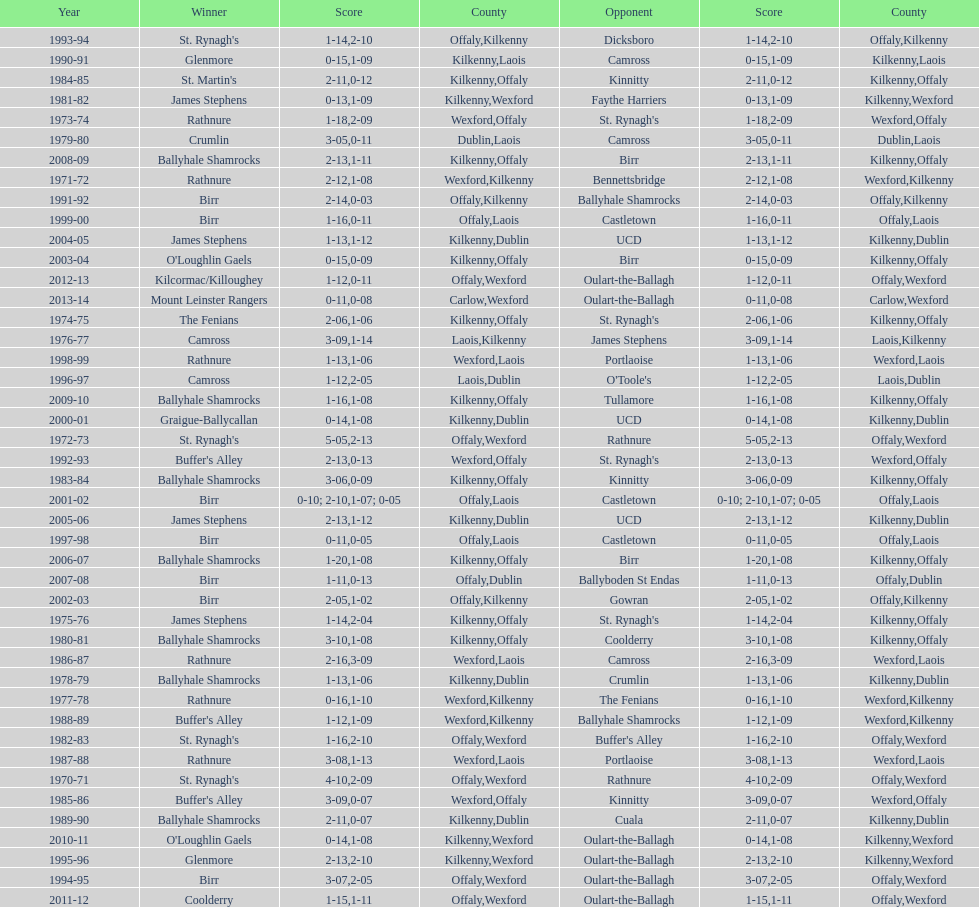James stephens won in 1976-76. who won three years before that? St. Rynagh's. Could you parse the entire table as a dict? {'header': ['Year', 'Winner', 'Score', 'County', 'Opponent', 'Score', 'County'], 'rows': [['1993-94', "St. Rynagh's", '1-14', 'Offaly', 'Dicksboro', '2-10', 'Kilkenny'], ['1990-91', 'Glenmore', '0-15', 'Kilkenny', 'Camross', '1-09', 'Laois'], ['1984-85', "St. Martin's", '2-11', 'Kilkenny', 'Kinnitty', '0-12', 'Offaly'], ['1981-82', 'James Stephens', '0-13', 'Kilkenny', 'Faythe Harriers', '1-09', 'Wexford'], ['1973-74', 'Rathnure', '1-18', 'Wexford', "St. Rynagh's", '2-09', 'Offaly'], ['1979-80', 'Crumlin', '3-05', 'Dublin', 'Camross', '0-11', 'Laois'], ['2008-09', 'Ballyhale Shamrocks', '2-13', 'Kilkenny', 'Birr', '1-11', 'Offaly'], ['1971-72', 'Rathnure', '2-12', 'Wexford', 'Bennettsbridge', '1-08', 'Kilkenny'], ['1991-92', 'Birr', '2-14', 'Offaly', 'Ballyhale Shamrocks', '0-03', 'Kilkenny'], ['1999-00', 'Birr', '1-16', 'Offaly', 'Castletown', '0-11', 'Laois'], ['2004-05', 'James Stephens', '1-13', 'Kilkenny', 'UCD', '1-12', 'Dublin'], ['2003-04', "O'Loughlin Gaels", '0-15', 'Kilkenny', 'Birr', '0-09', 'Offaly'], ['2012-13', 'Kilcormac/Killoughey', '1-12', 'Offaly', 'Oulart-the-Ballagh', '0-11', 'Wexford'], ['2013-14', 'Mount Leinster Rangers', '0-11', 'Carlow', 'Oulart-the-Ballagh', '0-08', 'Wexford'], ['1974-75', 'The Fenians', '2-06', 'Kilkenny', "St. Rynagh's", '1-06', 'Offaly'], ['1976-77', 'Camross', '3-09', 'Laois', 'James Stephens', '1-14', 'Kilkenny'], ['1998-99', 'Rathnure', '1-13', 'Wexford', 'Portlaoise', '1-06', 'Laois'], ['1996-97', 'Camross', '1-12', 'Laois', "O'Toole's", '2-05', 'Dublin'], ['2009-10', 'Ballyhale Shamrocks', '1-16', 'Kilkenny', 'Tullamore', '1-08', 'Offaly'], ['2000-01', 'Graigue-Ballycallan', '0-14', 'Kilkenny', 'UCD', '1-08', 'Dublin'], ['1972-73', "St. Rynagh's", '5-05', 'Offaly', 'Rathnure', '2-13', 'Wexford'], ['1992-93', "Buffer's Alley", '2-13', 'Wexford', "St. Rynagh's", '0-13', 'Offaly'], ['1983-84', 'Ballyhale Shamrocks', '3-06', 'Kilkenny', 'Kinnitty', '0-09', 'Offaly'], ['2001-02', 'Birr', '0-10; 2-10', 'Offaly', 'Castletown', '1-07; 0-05', 'Laois'], ['2005-06', 'James Stephens', '2-13', 'Kilkenny', 'UCD', '1-12', 'Dublin'], ['1997-98', 'Birr', '0-11', 'Offaly', 'Castletown', '0-05', 'Laois'], ['2006-07', 'Ballyhale Shamrocks', '1-20', 'Kilkenny', 'Birr', '1-08', 'Offaly'], ['2007-08', 'Birr', '1-11', 'Offaly', 'Ballyboden St Endas', '0-13', 'Dublin'], ['2002-03', 'Birr', '2-05', 'Offaly', 'Gowran', '1-02', 'Kilkenny'], ['1975-76', 'James Stephens', '1-14', 'Kilkenny', "St. Rynagh's", '2-04', 'Offaly'], ['1980-81', 'Ballyhale Shamrocks', '3-10', 'Kilkenny', 'Coolderry', '1-08', 'Offaly'], ['1986-87', 'Rathnure', '2-16', 'Wexford', 'Camross', '3-09', 'Laois'], ['1978-79', 'Ballyhale Shamrocks', '1-13', 'Kilkenny', 'Crumlin', '1-06', 'Dublin'], ['1977-78', 'Rathnure', '0-16', 'Wexford', 'The Fenians', '1-10', 'Kilkenny'], ['1988-89', "Buffer's Alley", '1-12', 'Wexford', 'Ballyhale Shamrocks', '1-09', 'Kilkenny'], ['1982-83', "St. Rynagh's", '1-16', 'Offaly', "Buffer's Alley", '2-10', 'Wexford'], ['1987-88', 'Rathnure', '3-08', 'Wexford', 'Portlaoise', '1-13', 'Laois'], ['1970-71', "St. Rynagh's", '4-10', 'Offaly', 'Rathnure', '2-09', 'Wexford'], ['1985-86', "Buffer's Alley", '3-09', 'Wexford', 'Kinnitty', '0-07', 'Offaly'], ['1989-90', 'Ballyhale Shamrocks', '2-11', 'Kilkenny', 'Cuala', '0-07', 'Dublin'], ['2010-11', "O'Loughlin Gaels", '0-14', 'Kilkenny', 'Oulart-the-Ballagh', '1-08', 'Wexford'], ['1995-96', 'Glenmore', '2-13', 'Kilkenny', 'Oulart-the-Ballagh', '2-10', 'Wexford'], ['1994-95', 'Birr', '3-07', 'Offaly', 'Oulart-the-Ballagh', '2-05', 'Wexford'], ['2011-12', 'Coolderry', '1-15', 'Offaly', 'Oulart-the-Ballagh', '1-11', 'Wexford']]} 